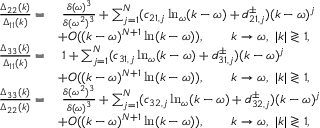Convert formula to latex. <formula><loc_0><loc_0><loc_500><loc_500>\begin{array} { r l } { \frac { \Delta _ { 2 2 } ( k ) } { \Delta _ { 1 1 } ( k ) } = } & { \, \frac { \delta ( \omega ) ^ { 3 } } { \delta ( \omega ^ { 2 } ) ^ { 3 } } + \sum _ { j = 1 } ^ { N } ( c _ { 2 1 , j } \ln _ { \omega } ( k - \omega ) + d _ { 2 1 , j } ^ { \pm } ) ( k - \omega ) ^ { j } } \\ & { + O ( ( k - \omega ) ^ { N + 1 } \ln ( k - \omega ) ) , \quad k \to \omega , \ | k | \gtrless 1 , } \\ { \frac { \Delta _ { 3 3 } ( k ) } { \Delta _ { 1 1 } ( k ) } = } & { \, 1 + \sum _ { j = 1 } ^ { N } ( c _ { 3 1 , j } \ln _ { \omega } ( k - \omega ) + d _ { 3 1 , j } ^ { \pm } ) ( k - \omega ) ^ { j } } \\ & { + O ( ( k - \omega ) ^ { N + 1 } \ln ( k - \omega ) ) , \quad k \to \omega , \ | k | \gtrless 1 , } \\ { \frac { \Delta _ { 3 3 } ( k ) } { \Delta _ { 2 2 } ( k ) } = } & { \, \frac { \delta ( \omega ^ { 2 } ) ^ { 3 } } { \delta ( \omega ) ^ { 3 } } + \sum _ { j = 1 } ^ { N } ( c _ { 3 2 , j } \ln _ { \omega } ( k - \omega ) + d _ { 3 2 , j } ^ { \pm } ) ( k - \omega ) ^ { j } } \\ & { + O ( ( k - \omega ) ^ { N + 1 } \ln ( k - \omega ) ) , \quad k \to \omega , \ | k | \gtrless 1 , } \end{array}</formula> 